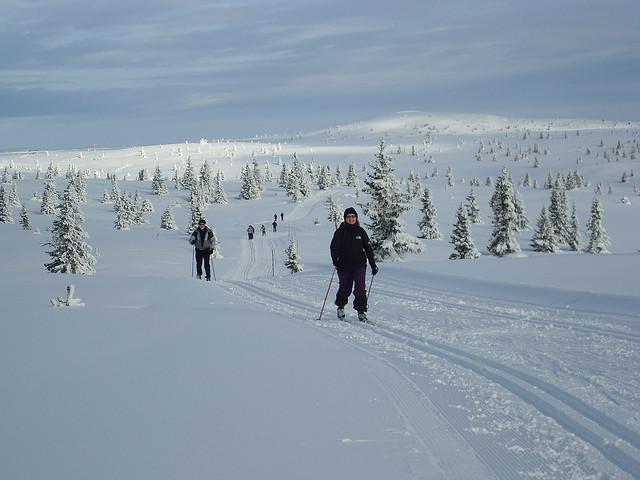How many green coats are being worn?
Give a very brief answer. 0. 